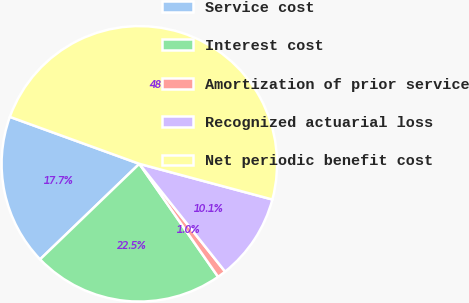<chart> <loc_0><loc_0><loc_500><loc_500><pie_chart><fcel>Service cost<fcel>Interest cost<fcel>Amortization of prior service<fcel>Recognized actuarial loss<fcel>Net periodic benefit cost<nl><fcel>17.73%<fcel>22.49%<fcel>1.01%<fcel>10.13%<fcel>48.63%<nl></chart> 